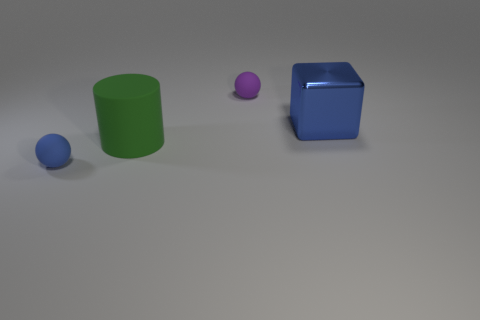What is the size of the other object that is the same shape as the small blue object? The object that has the same cube shape as the small blue one is significantly larger in size. 